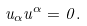<formula> <loc_0><loc_0><loc_500><loc_500>u _ { \alpha } u ^ { \alpha } = 0 .</formula> 